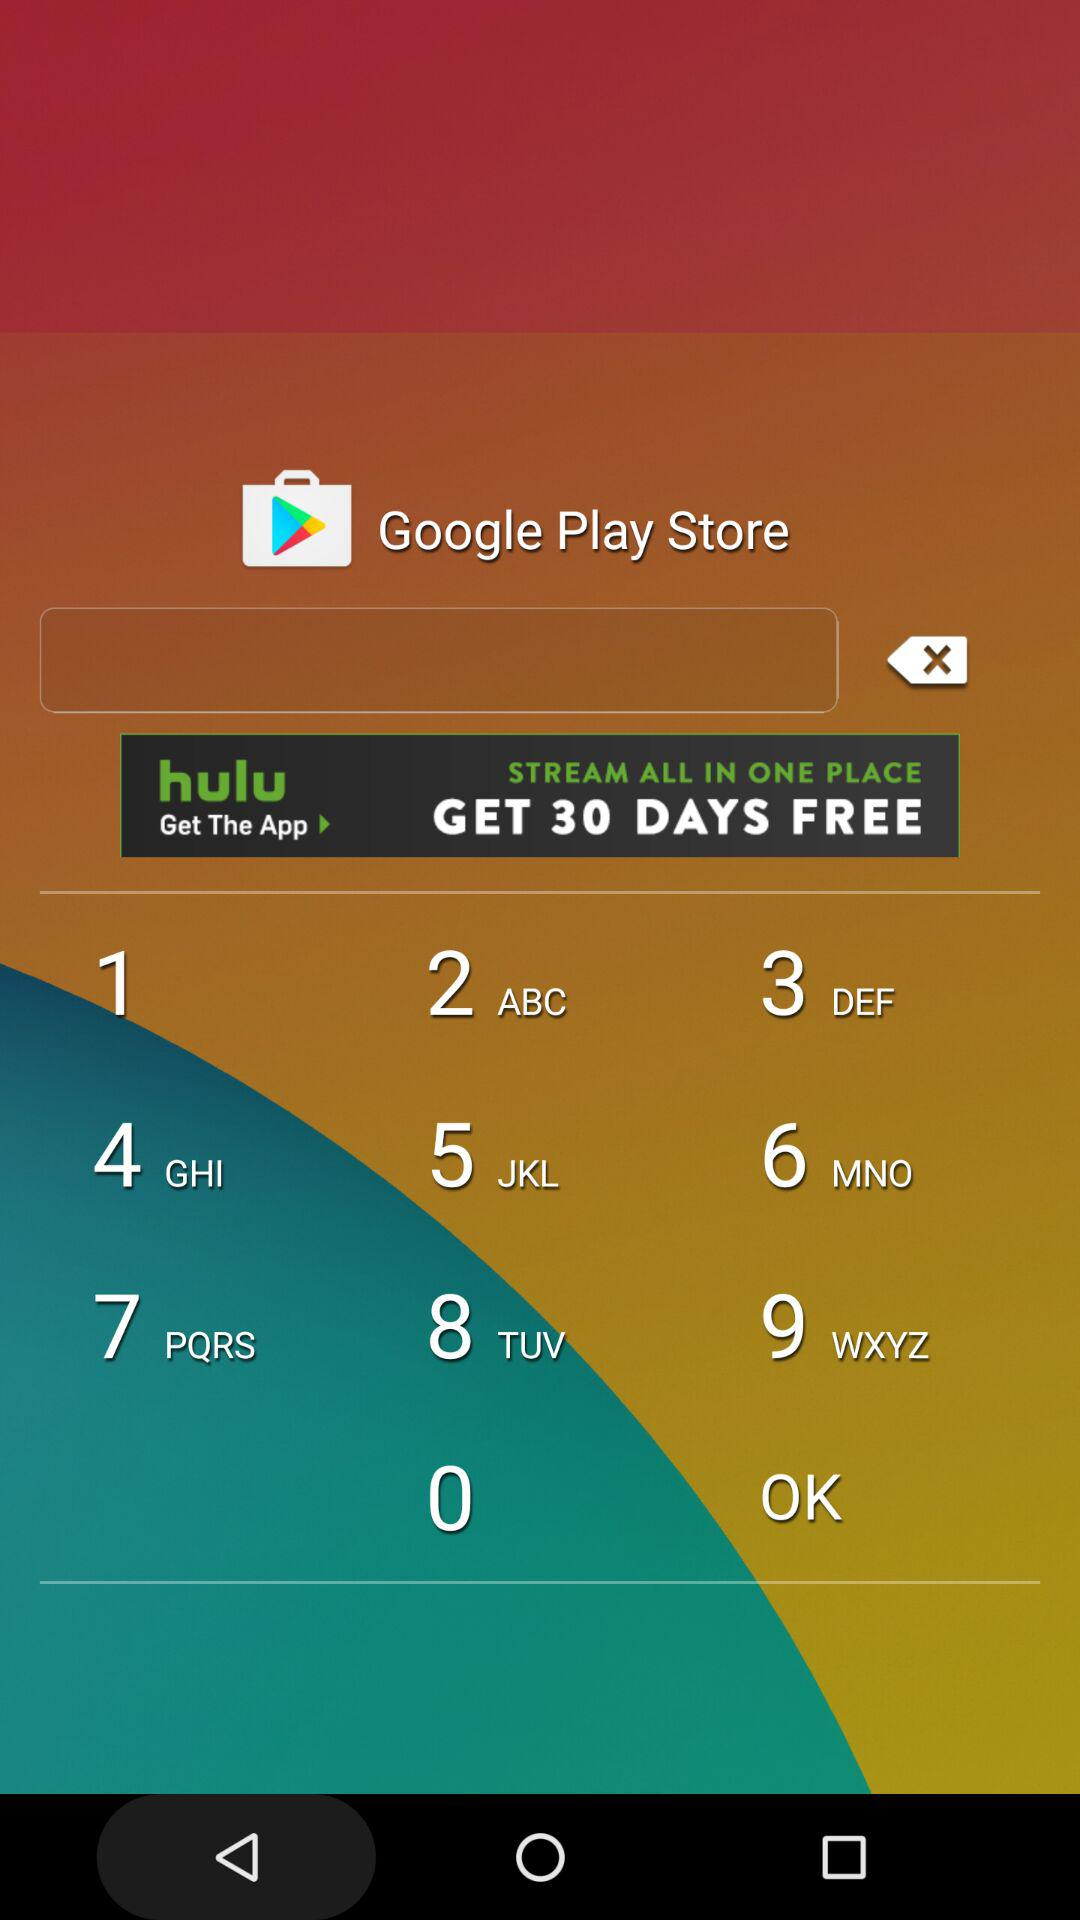At what time is the claiming race scheduled? The claiming race is scheduled for 11:55 AM. 